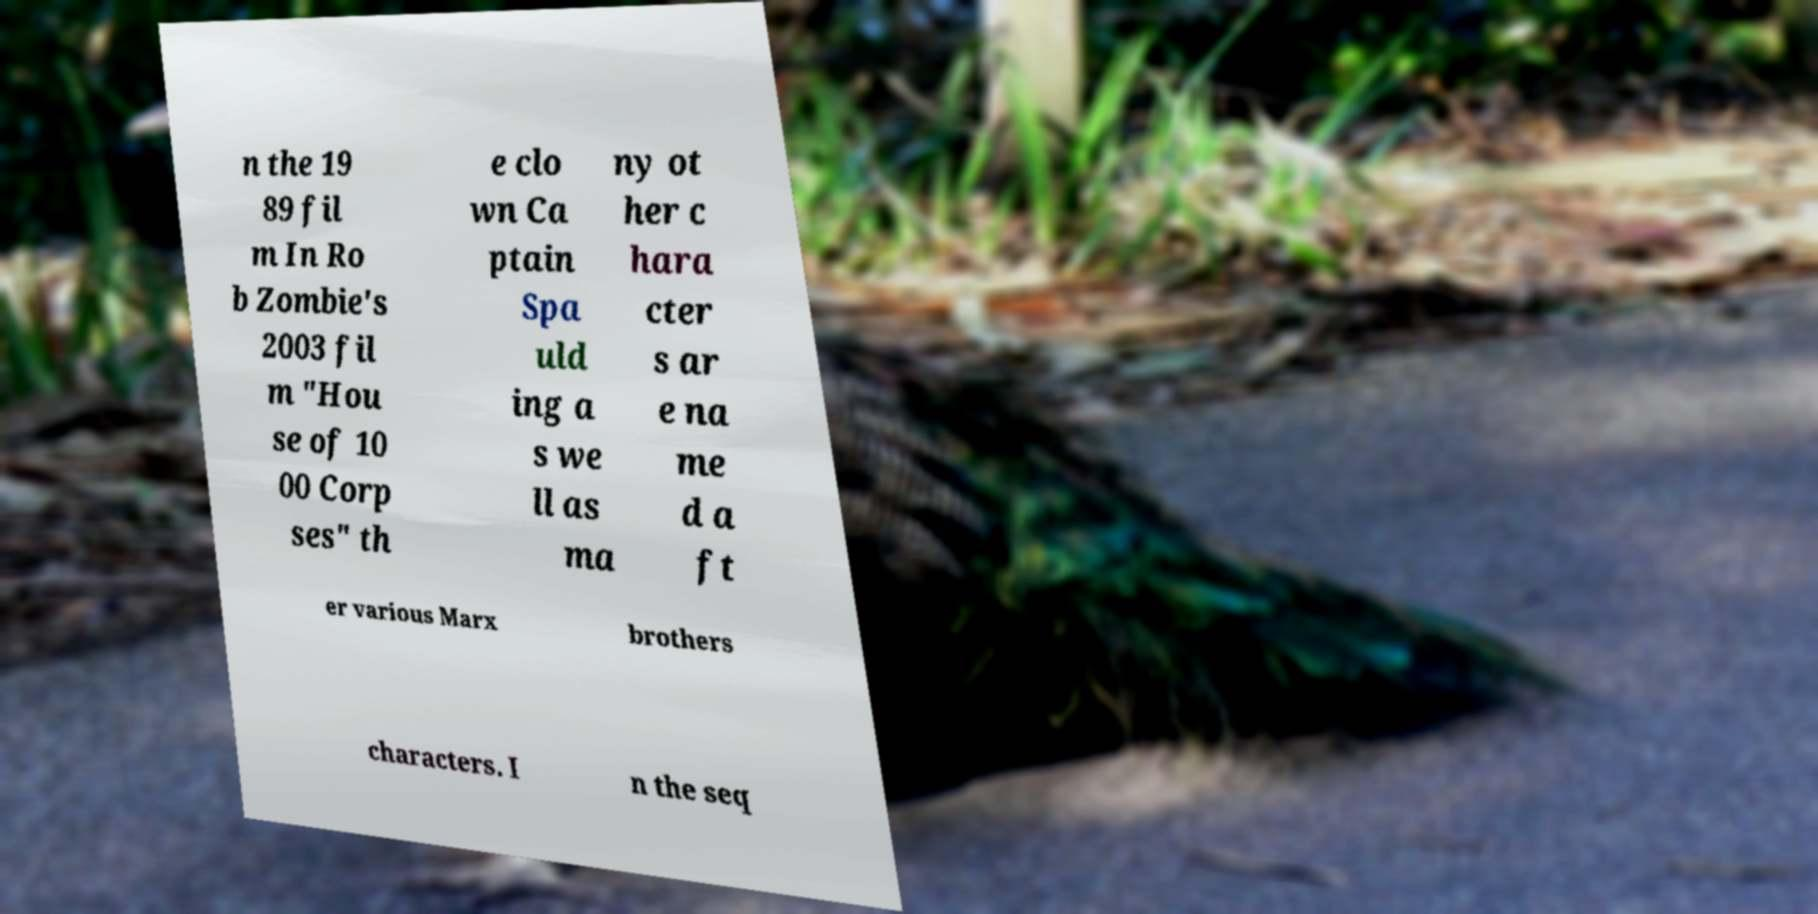Please read and relay the text visible in this image. What does it say? n the 19 89 fil m In Ro b Zombie's 2003 fil m "Hou se of 10 00 Corp ses" th e clo wn Ca ptain Spa uld ing a s we ll as ma ny ot her c hara cter s ar e na me d a ft er various Marx brothers characters. I n the seq 